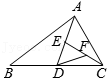Clarify your interpretation of the image. The diagram exhibits a triangle labeled ABC. Along the sides BC, AD, and CE, there are points D, E, and F correspondingly. The area of the triangle is 4cm^2. 